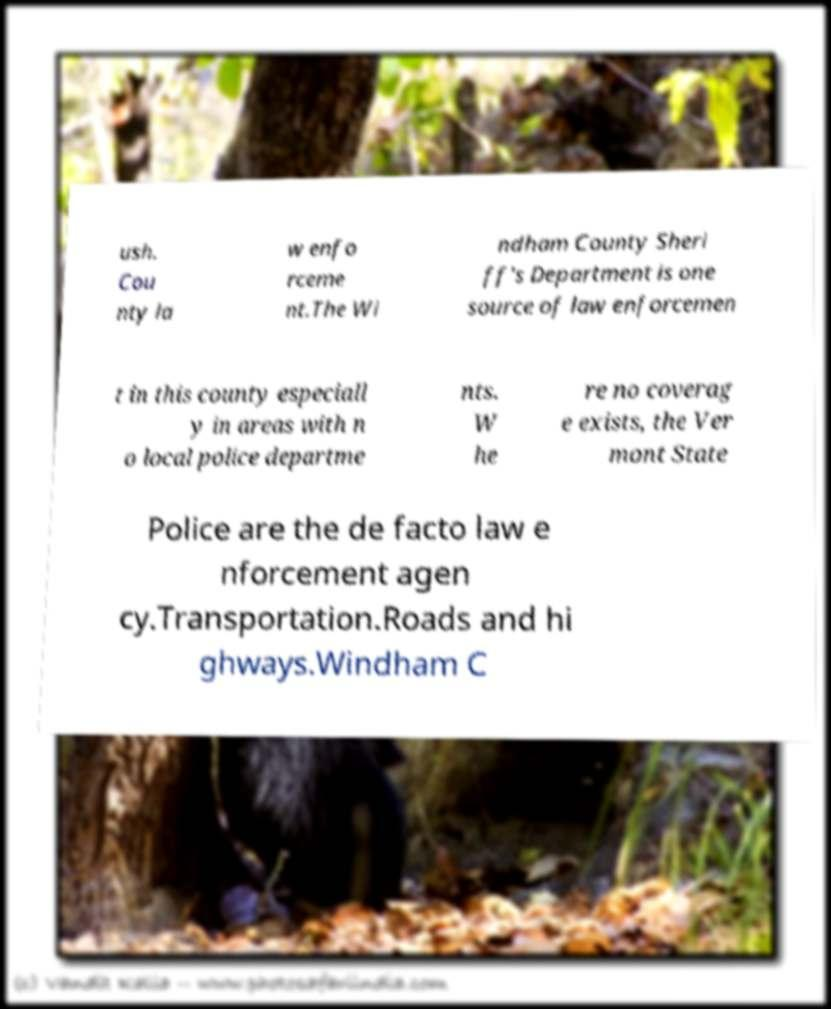Could you assist in decoding the text presented in this image and type it out clearly? ush. Cou nty la w enfo rceme nt.The Wi ndham County Sheri ff's Department is one source of law enforcemen t in this county especiall y in areas with n o local police departme nts. W he re no coverag e exists, the Ver mont State Police are the de facto law e nforcement agen cy.Transportation.Roads and hi ghways.Windham C 